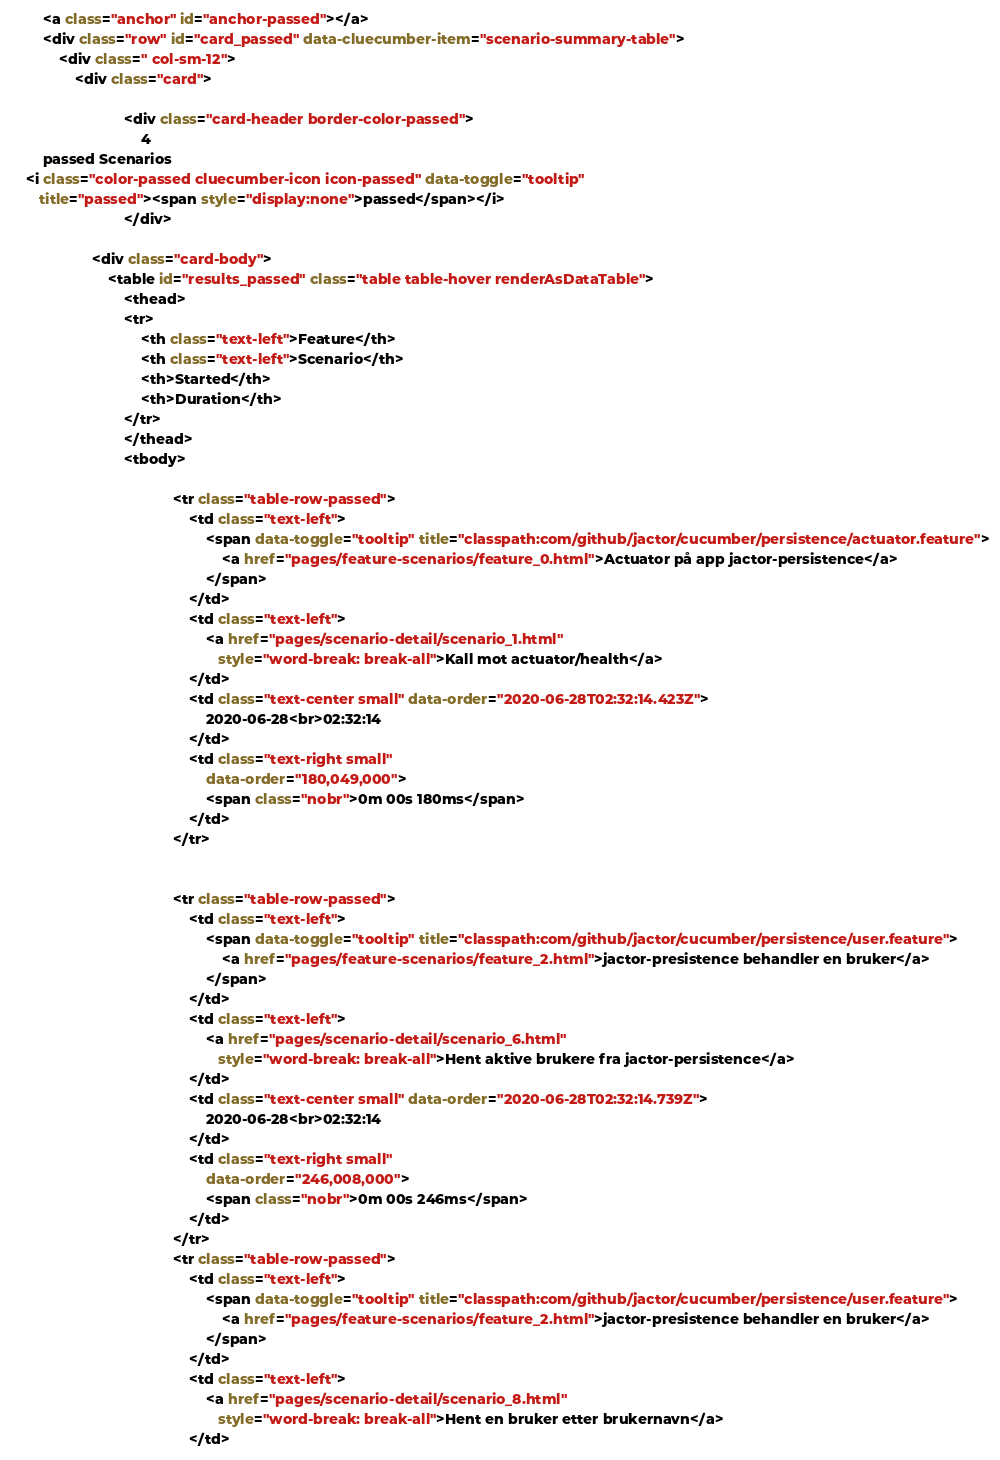Convert code to text. <code><loc_0><loc_0><loc_500><loc_500><_HTML_>
        <a class="anchor" id="anchor-passed"></a>
        <div class="row" id="card_passed" data-cluecumber-item="scenario-summary-table">
            <div class=" col-sm-12">
                <div class="card">

                            <div class="card-header border-color-passed">
                                4
        passed Scenarios
    <i class="color-passed cluecumber-icon icon-passed" data-toggle="tooltip"
       title="passed"><span style="display:none">passed</span></i>
                            </div>

                    <div class="card-body">
                        <table id="results_passed" class="table table-hover renderAsDataTable">
                            <thead>
                            <tr>
                                <th class="text-left">Feature</th>
                                <th class="text-left">Scenario</th>
                                <th>Started</th>
                                <th>Duration</th>
                            </tr>
                            </thead>
                            <tbody>

                                        <tr class="table-row-passed">
                                            <td class="text-left">
                                                <span data-toggle="tooltip" title="classpath:com/github/jactor/cucumber/persistence/actuator.feature">
                                                    <a href="pages/feature-scenarios/feature_0.html">Actuator på app jactor-persistence</a>
                                                </span>
                                            </td>
                                            <td class="text-left">
                                                <a href="pages/scenario-detail/scenario_1.html"
                                                   style="word-break: break-all">Kall mot actuator/health</a>
                                            </td>
                                            <td class="text-center small" data-order="2020-06-28T02:32:14.423Z">
                                                2020-06-28<br>02:32:14
                                            </td>
                                            <td class="text-right small"
                                                data-order="180,049,000">
                                                <span class="nobr">0m 00s 180ms</span>
                                            </td>
                                        </tr>


                                        <tr class="table-row-passed">
                                            <td class="text-left">
                                                <span data-toggle="tooltip" title="classpath:com/github/jactor/cucumber/persistence/user.feature">
                                                    <a href="pages/feature-scenarios/feature_2.html">jactor-presistence behandler en bruker</a>
                                                </span>
                                            </td>
                                            <td class="text-left">
                                                <a href="pages/scenario-detail/scenario_6.html"
                                                   style="word-break: break-all">Hent aktive brukere fra jactor-persistence</a>
                                            </td>
                                            <td class="text-center small" data-order="2020-06-28T02:32:14.739Z">
                                                2020-06-28<br>02:32:14
                                            </td>
                                            <td class="text-right small"
                                                data-order="246,008,000">
                                                <span class="nobr">0m 00s 246ms</span>
                                            </td>
                                        </tr>
                                        <tr class="table-row-passed">
                                            <td class="text-left">
                                                <span data-toggle="tooltip" title="classpath:com/github/jactor/cucumber/persistence/user.feature">
                                                    <a href="pages/feature-scenarios/feature_2.html">jactor-presistence behandler en bruker</a>
                                                </span>
                                            </td>
                                            <td class="text-left">
                                                <a href="pages/scenario-detail/scenario_8.html"
                                                   style="word-break: break-all">Hent en bruker etter brukernavn</a>
                                            </td></code> 